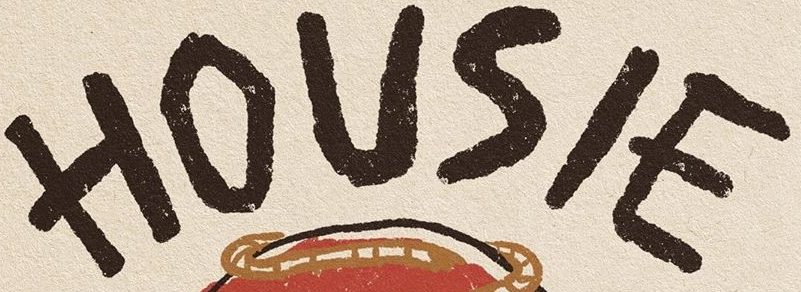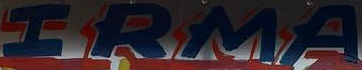Identify the words shown in these images in order, separated by a semicolon. HOUSIE; IRMA 